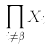Convert formula to latex. <formula><loc_0><loc_0><loc_500><loc_500>\prod _ { i \ne \beta } X _ { i }</formula> 